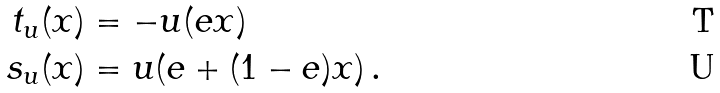Convert formula to latex. <formula><loc_0><loc_0><loc_500><loc_500>t _ { u } ( x ) & = - u ( e x ) \\ s _ { u } ( x ) & = u ( e + ( 1 - e ) x ) \, .</formula> 